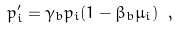<formula> <loc_0><loc_0><loc_500><loc_500>p ^ { \prime } _ { i } = \gamma _ { b } p _ { i } ( 1 - \beta _ { b } \mu _ { i } ) \ ,</formula> 